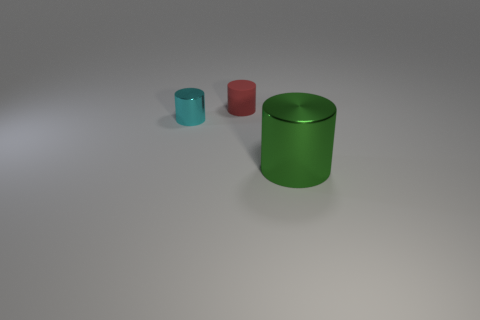Subtract all tiny cyan cylinders. How many cylinders are left? 2 Add 3 tiny green rubber blocks. How many objects exist? 6 Subtract 1 cylinders. How many cylinders are left? 2 Subtract all tiny cyan metallic objects. Subtract all big purple rubber cubes. How many objects are left? 2 Add 2 cyan metal cylinders. How many cyan metal cylinders are left? 3 Add 1 big green things. How many big green things exist? 2 Subtract all red cylinders. How many cylinders are left? 2 Subtract 0 gray spheres. How many objects are left? 3 Subtract all red cylinders. Subtract all red blocks. How many cylinders are left? 2 